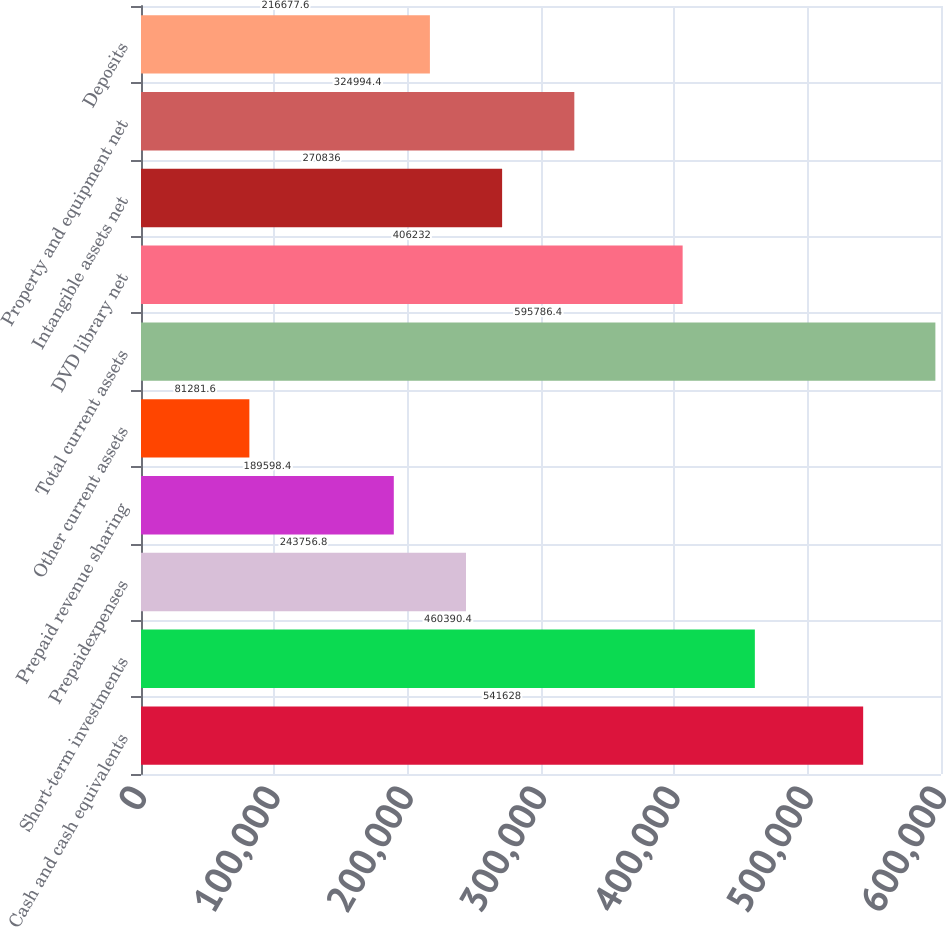<chart> <loc_0><loc_0><loc_500><loc_500><bar_chart><fcel>Cash and cash equivalents<fcel>Short-term investments<fcel>Prepaidexpenses<fcel>Prepaid revenue sharing<fcel>Other current assets<fcel>Total current assets<fcel>DVD library net<fcel>Intangible assets net<fcel>Property and equipment net<fcel>Deposits<nl><fcel>541628<fcel>460390<fcel>243757<fcel>189598<fcel>81281.6<fcel>595786<fcel>406232<fcel>270836<fcel>324994<fcel>216678<nl></chart> 